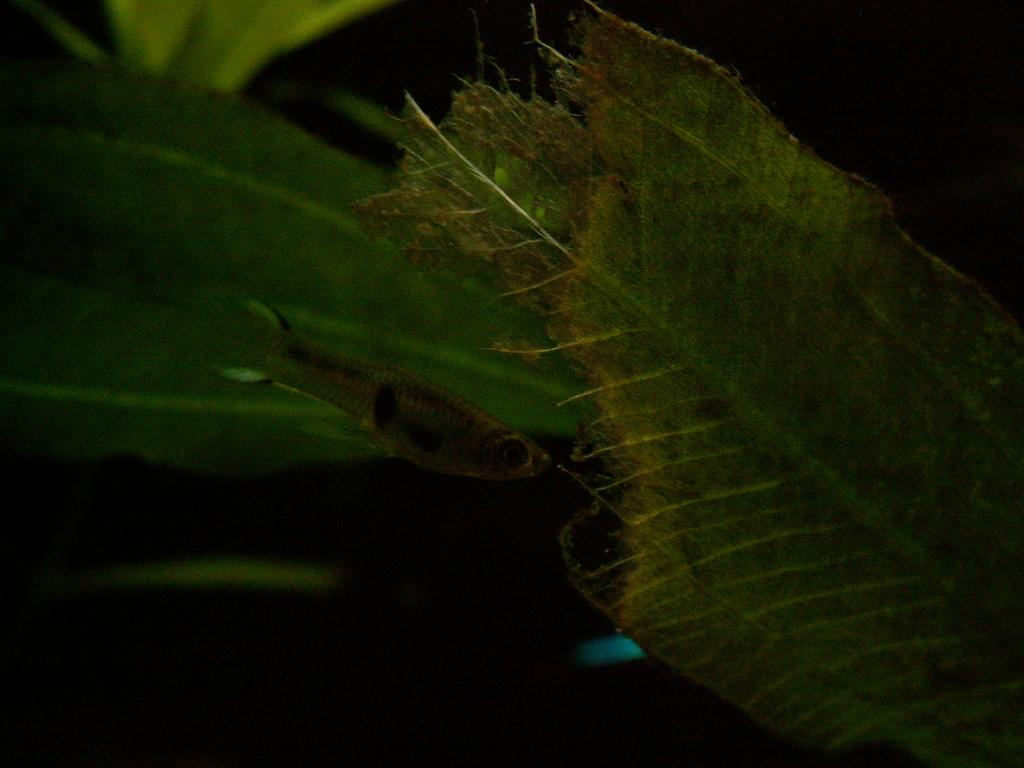What is the primary subject in the image? There is a leaf in the image. Are there any other living creatures or objects in the image? Yes, there is a fish in the image, positioned to the side. What type of lamp is positioned next to the fish in the image? There is no lamp present in the image; it only features a leaf and a fish. 